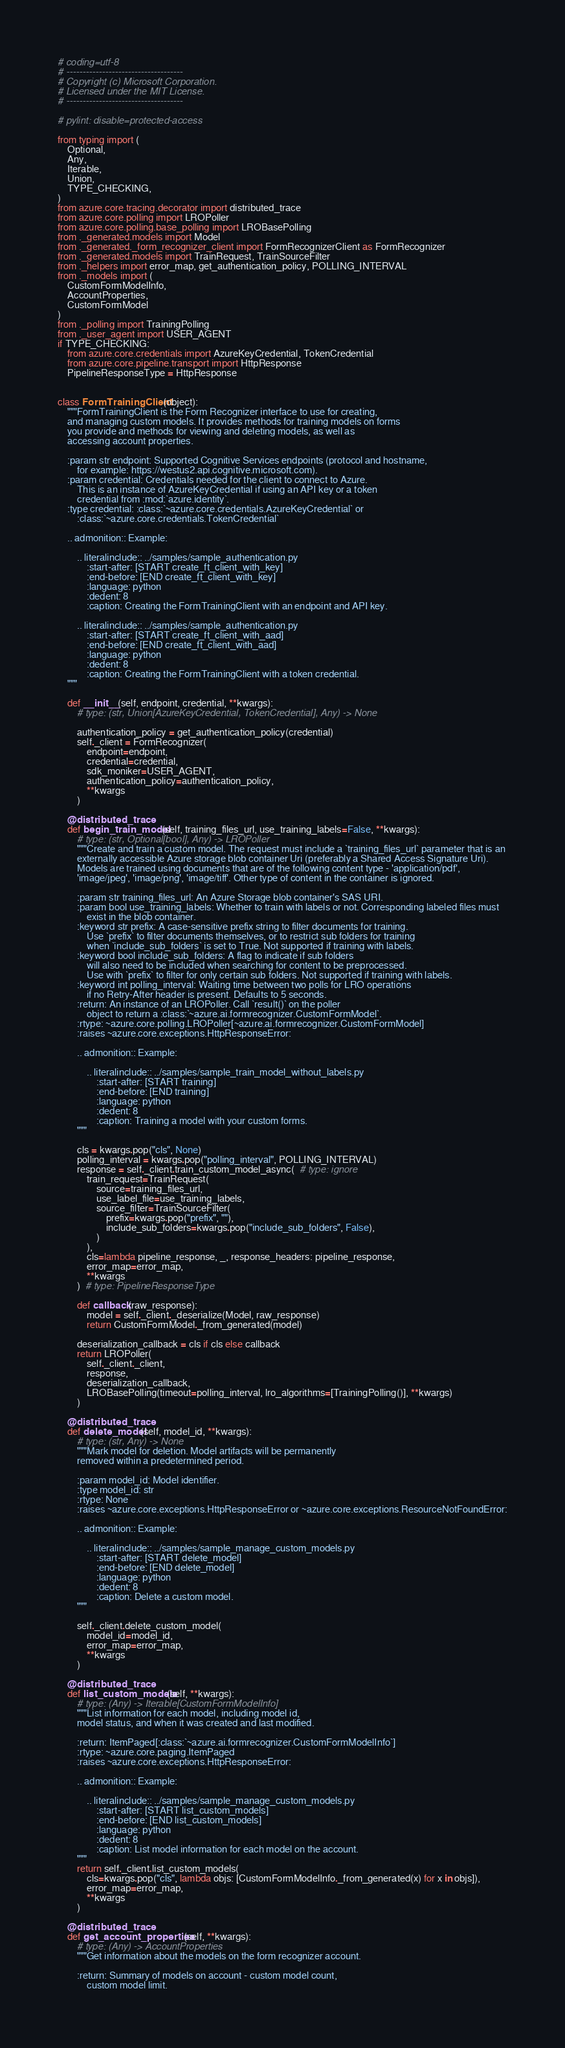<code> <loc_0><loc_0><loc_500><loc_500><_Python_># coding=utf-8
# ------------------------------------
# Copyright (c) Microsoft Corporation.
# Licensed under the MIT License.
# ------------------------------------

# pylint: disable=protected-access

from typing import (
    Optional,
    Any,
    Iterable,
    Union,
    TYPE_CHECKING,
)
from azure.core.tracing.decorator import distributed_trace
from azure.core.polling import LROPoller
from azure.core.polling.base_polling import LROBasePolling
from ._generated.models import Model
from ._generated._form_recognizer_client import FormRecognizerClient as FormRecognizer
from ._generated.models import TrainRequest, TrainSourceFilter
from ._helpers import error_map, get_authentication_policy, POLLING_INTERVAL
from ._models import (
    CustomFormModelInfo,
    AccountProperties,
    CustomFormModel
)
from ._polling import TrainingPolling
from ._user_agent import USER_AGENT
if TYPE_CHECKING:
    from azure.core.credentials import AzureKeyCredential, TokenCredential
    from azure.core.pipeline.transport import HttpResponse
    PipelineResponseType = HttpResponse


class FormTrainingClient(object):
    """FormTrainingClient is the Form Recognizer interface to use for creating,
    and managing custom models. It provides methods for training models on forms
    you provide and methods for viewing and deleting models, as well as
    accessing account properties.

    :param str endpoint: Supported Cognitive Services endpoints (protocol and hostname,
        for example: https://westus2.api.cognitive.microsoft.com).
    :param credential: Credentials needed for the client to connect to Azure.
        This is an instance of AzureKeyCredential if using an API key or a token
        credential from :mod:`azure.identity`.
    :type credential: :class:`~azure.core.credentials.AzureKeyCredential` or
        :class:`~azure.core.credentials.TokenCredential`

    .. admonition:: Example:

        .. literalinclude:: ../samples/sample_authentication.py
            :start-after: [START create_ft_client_with_key]
            :end-before: [END create_ft_client_with_key]
            :language: python
            :dedent: 8
            :caption: Creating the FormTrainingClient with an endpoint and API key.

        .. literalinclude:: ../samples/sample_authentication.py
            :start-after: [START create_ft_client_with_aad]
            :end-before: [END create_ft_client_with_aad]
            :language: python
            :dedent: 8
            :caption: Creating the FormTrainingClient with a token credential.
    """

    def __init__(self, endpoint, credential, **kwargs):
        # type: (str, Union[AzureKeyCredential, TokenCredential], Any) -> None

        authentication_policy = get_authentication_policy(credential)
        self._client = FormRecognizer(
            endpoint=endpoint,
            credential=credential,
            sdk_moniker=USER_AGENT,
            authentication_policy=authentication_policy,
            **kwargs
        )

    @distributed_trace
    def begin_train_model(self, training_files_url, use_training_labels=False, **kwargs):
        # type: (str, Optional[bool], Any) -> LROPoller
        """Create and train a custom model. The request must include a `training_files_url` parameter that is an
        externally accessible Azure storage blob container Uri (preferably a Shared Access Signature Uri).
        Models are trained using documents that are of the following content type - 'application/pdf',
        'image/jpeg', 'image/png', 'image/tiff'. Other type of content in the container is ignored.

        :param str training_files_url: An Azure Storage blob container's SAS URI.
        :param bool use_training_labels: Whether to train with labels or not. Corresponding labeled files must
            exist in the blob container.
        :keyword str prefix: A case-sensitive prefix string to filter documents for training.
            Use `prefix` to filter documents themselves, or to restrict sub folders for training
            when `include_sub_folders` is set to True. Not supported if training with labels.
        :keyword bool include_sub_folders: A flag to indicate if sub folders
            will also need to be included when searching for content to be preprocessed.
            Use with `prefix` to filter for only certain sub folders. Not supported if training with labels.
        :keyword int polling_interval: Waiting time between two polls for LRO operations
            if no Retry-After header is present. Defaults to 5 seconds.
        :return: An instance of an LROPoller. Call `result()` on the poller
            object to return a :class:`~azure.ai.formrecognizer.CustomFormModel`.
        :rtype: ~azure.core.polling.LROPoller[~azure.ai.formrecognizer.CustomFormModel]
        :raises ~azure.core.exceptions.HttpResponseError:

        .. admonition:: Example:

            .. literalinclude:: ../samples/sample_train_model_without_labels.py
                :start-after: [START training]
                :end-before: [END training]
                :language: python
                :dedent: 8
                :caption: Training a model with your custom forms.
        """

        cls = kwargs.pop("cls", None)
        polling_interval = kwargs.pop("polling_interval", POLLING_INTERVAL)
        response = self._client.train_custom_model_async(  # type: ignore
            train_request=TrainRequest(
                source=training_files_url,
                use_label_file=use_training_labels,
                source_filter=TrainSourceFilter(
                    prefix=kwargs.pop("prefix", ""),
                    include_sub_folders=kwargs.pop("include_sub_folders", False),
                )
            ),
            cls=lambda pipeline_response, _, response_headers: pipeline_response,
            error_map=error_map,
            **kwargs
        )  # type: PipelineResponseType

        def callback(raw_response):
            model = self._client._deserialize(Model, raw_response)
            return CustomFormModel._from_generated(model)

        deserialization_callback = cls if cls else callback
        return LROPoller(
            self._client._client,
            response,
            deserialization_callback,
            LROBasePolling(timeout=polling_interval, lro_algorithms=[TrainingPolling()], **kwargs)
        )

    @distributed_trace
    def delete_model(self, model_id, **kwargs):
        # type: (str, Any) -> None
        """Mark model for deletion. Model artifacts will be permanently
        removed within a predetermined period.

        :param model_id: Model identifier.
        :type model_id: str
        :rtype: None
        :raises ~azure.core.exceptions.HttpResponseError or ~azure.core.exceptions.ResourceNotFoundError:

        .. admonition:: Example:

            .. literalinclude:: ../samples/sample_manage_custom_models.py
                :start-after: [START delete_model]
                :end-before: [END delete_model]
                :language: python
                :dedent: 8
                :caption: Delete a custom model.
        """

        self._client.delete_custom_model(
            model_id=model_id,
            error_map=error_map,
            **kwargs
        )

    @distributed_trace
    def list_custom_models(self, **kwargs):
        # type: (Any) -> Iterable[CustomFormModelInfo]
        """List information for each model, including model id,
        model status, and when it was created and last modified.

        :return: ItemPaged[:class:`~azure.ai.formrecognizer.CustomFormModelInfo`]
        :rtype: ~azure.core.paging.ItemPaged
        :raises ~azure.core.exceptions.HttpResponseError:

        .. admonition:: Example:

            .. literalinclude:: ../samples/sample_manage_custom_models.py
                :start-after: [START list_custom_models]
                :end-before: [END list_custom_models]
                :language: python
                :dedent: 8
                :caption: List model information for each model on the account.
        """
        return self._client.list_custom_models(
            cls=kwargs.pop("cls", lambda objs: [CustomFormModelInfo._from_generated(x) for x in objs]),
            error_map=error_map,
            **kwargs
        )

    @distributed_trace
    def get_account_properties(self, **kwargs):
        # type: (Any) -> AccountProperties
        """Get information about the models on the form recognizer account.

        :return: Summary of models on account - custom model count,
            custom model limit.</code> 